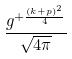<formula> <loc_0><loc_0><loc_500><loc_500>\frac { g ^ { + \frac { ( k + p ) ^ { 2 } } { 4 } } } { \sqrt { 4 \pi } }</formula> 